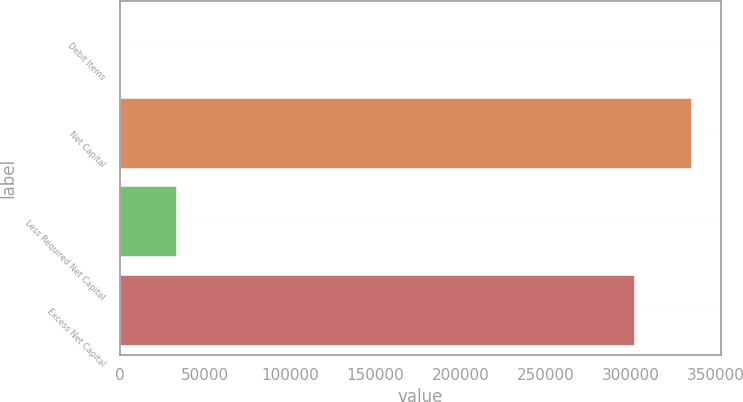Convert chart to OTSL. <chart><loc_0><loc_0><loc_500><loc_500><bar_chart><fcel>Debit Items<fcel>Net Capital<fcel>Less Required Net Capital<fcel>Excess Net Capital<nl><fcel>21.94<fcel>335814<fcel>33307.1<fcel>302529<nl></chart> 